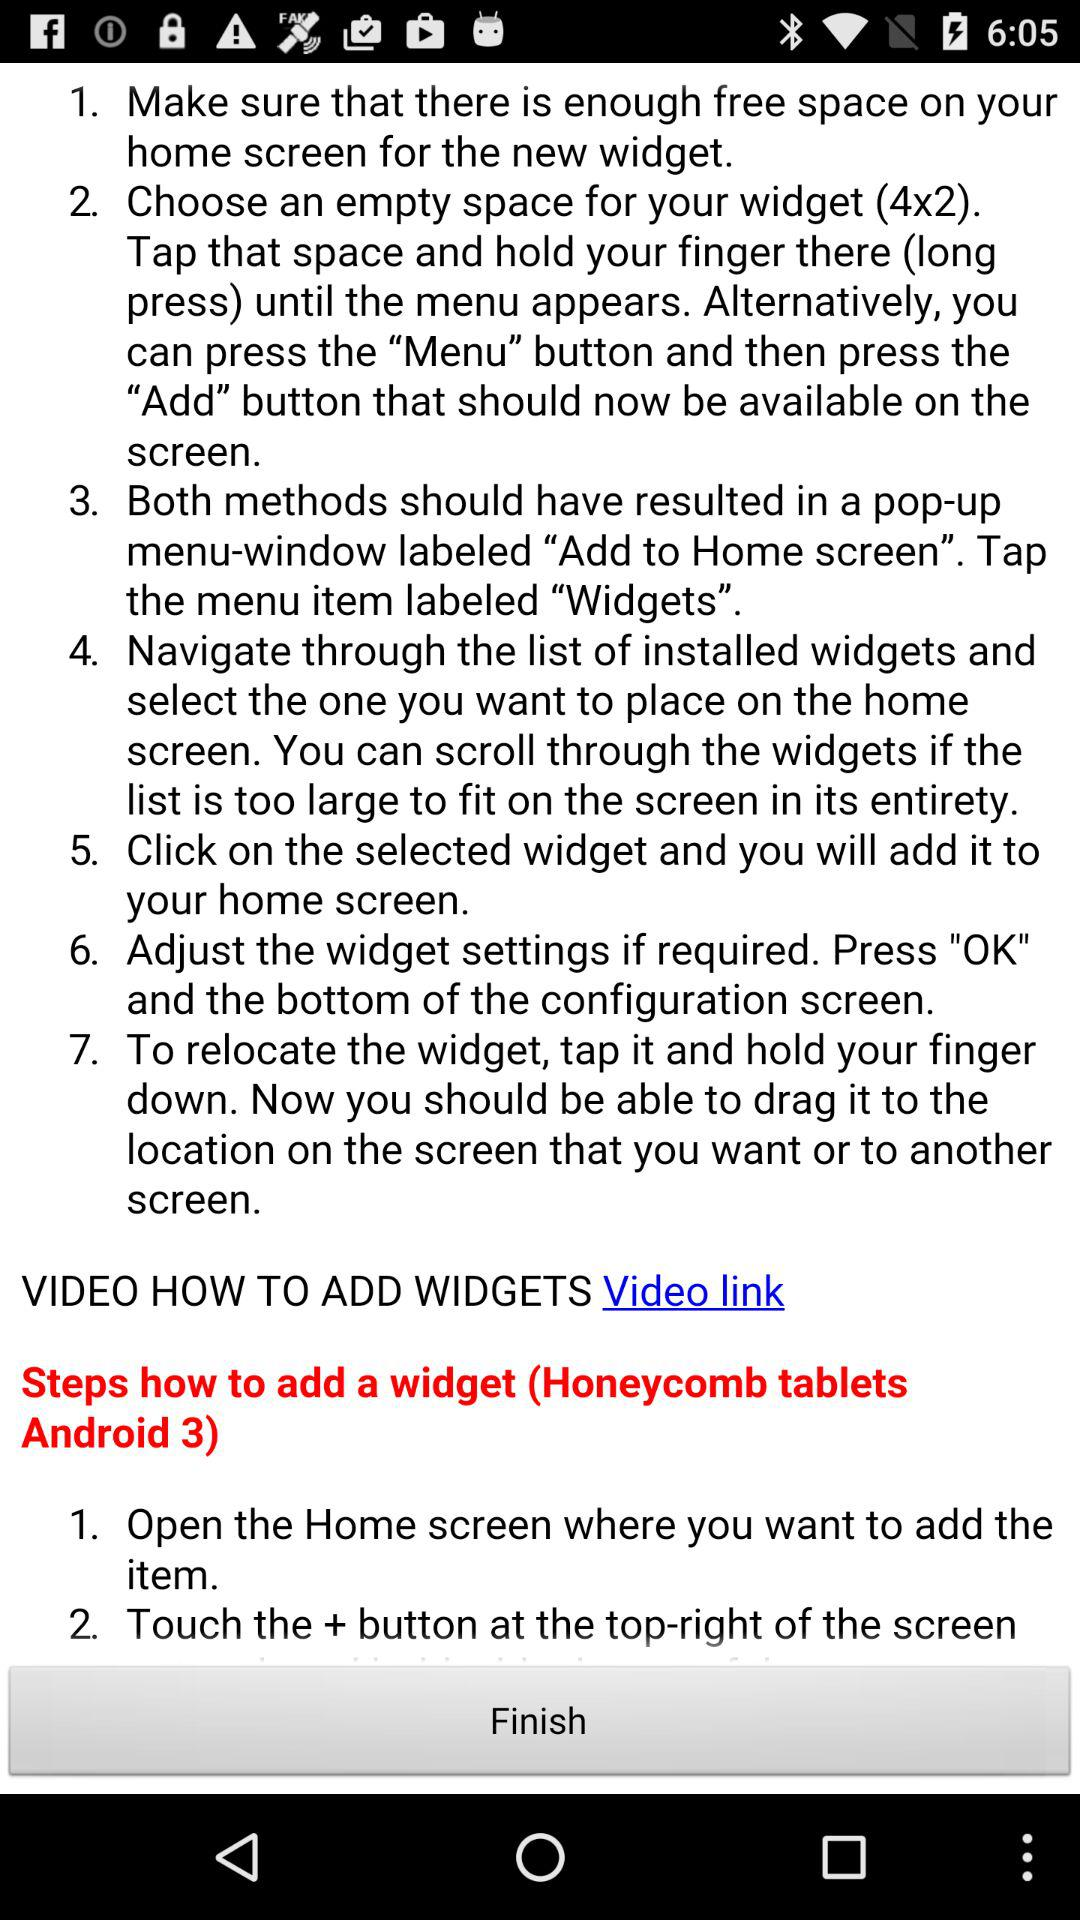How many steps in total are there in the instructions?
Answer the question using a single word or phrase. 7 